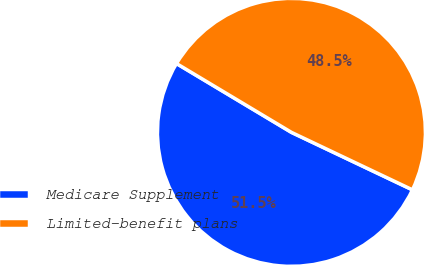Convert chart to OTSL. <chart><loc_0><loc_0><loc_500><loc_500><pie_chart><fcel>Medicare Supplement<fcel>Limited-benefit plans<nl><fcel>51.53%<fcel>48.47%<nl></chart> 